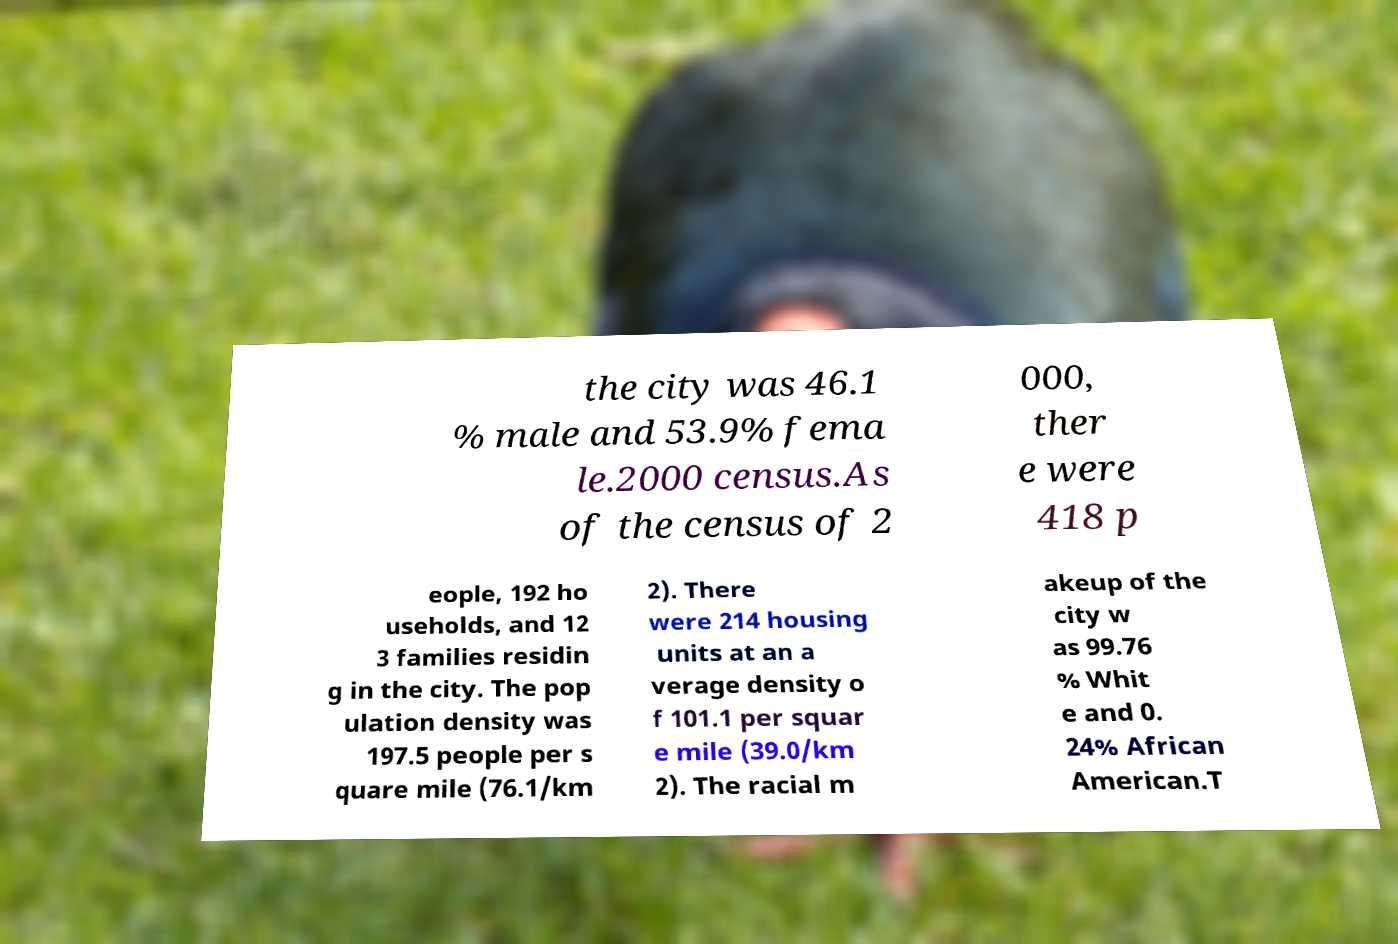Please identify and transcribe the text found in this image. the city was 46.1 % male and 53.9% fema le.2000 census.As of the census of 2 000, ther e were 418 p eople, 192 ho useholds, and 12 3 families residin g in the city. The pop ulation density was 197.5 people per s quare mile (76.1/km 2). There were 214 housing units at an a verage density o f 101.1 per squar e mile (39.0/km 2). The racial m akeup of the city w as 99.76 % Whit e and 0. 24% African American.T 